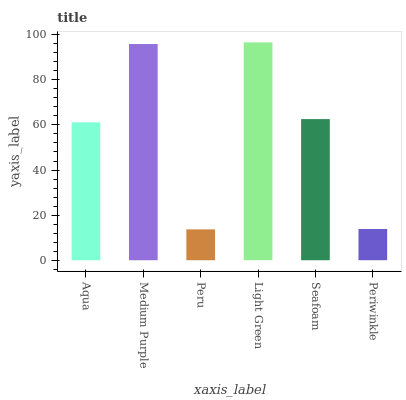Is Peru the minimum?
Answer yes or no. Yes. Is Light Green the maximum?
Answer yes or no. Yes. Is Medium Purple the minimum?
Answer yes or no. No. Is Medium Purple the maximum?
Answer yes or no. No. Is Medium Purple greater than Aqua?
Answer yes or no. Yes. Is Aqua less than Medium Purple?
Answer yes or no. Yes. Is Aqua greater than Medium Purple?
Answer yes or no. No. Is Medium Purple less than Aqua?
Answer yes or no. No. Is Seafoam the high median?
Answer yes or no. Yes. Is Aqua the low median?
Answer yes or no. Yes. Is Medium Purple the high median?
Answer yes or no. No. Is Peru the low median?
Answer yes or no. No. 